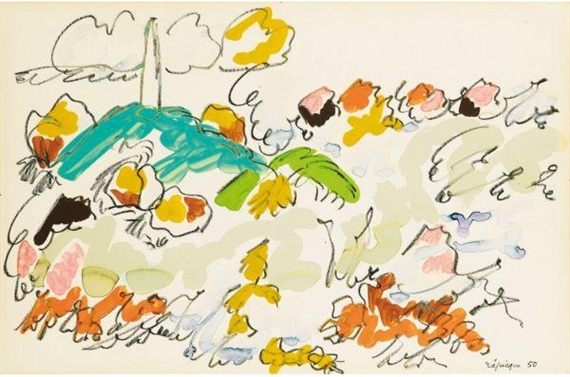Can you tell how the choice of colors impacts the mood of the artwork? The artist's choice of bright and contrasting colors such as yellow, orange, blue, and green against a white background with gray accents creates a lively and energetic mood. These color choices evoke a sense of joy and vibrancy, possibly reflecting the blithe spirit or an abstract representation of a natural scene. The way colors blend and contrast with each other also adds a layer of depth and emotion to the painting, stimulating the viewer’s imagination and emotional response. 